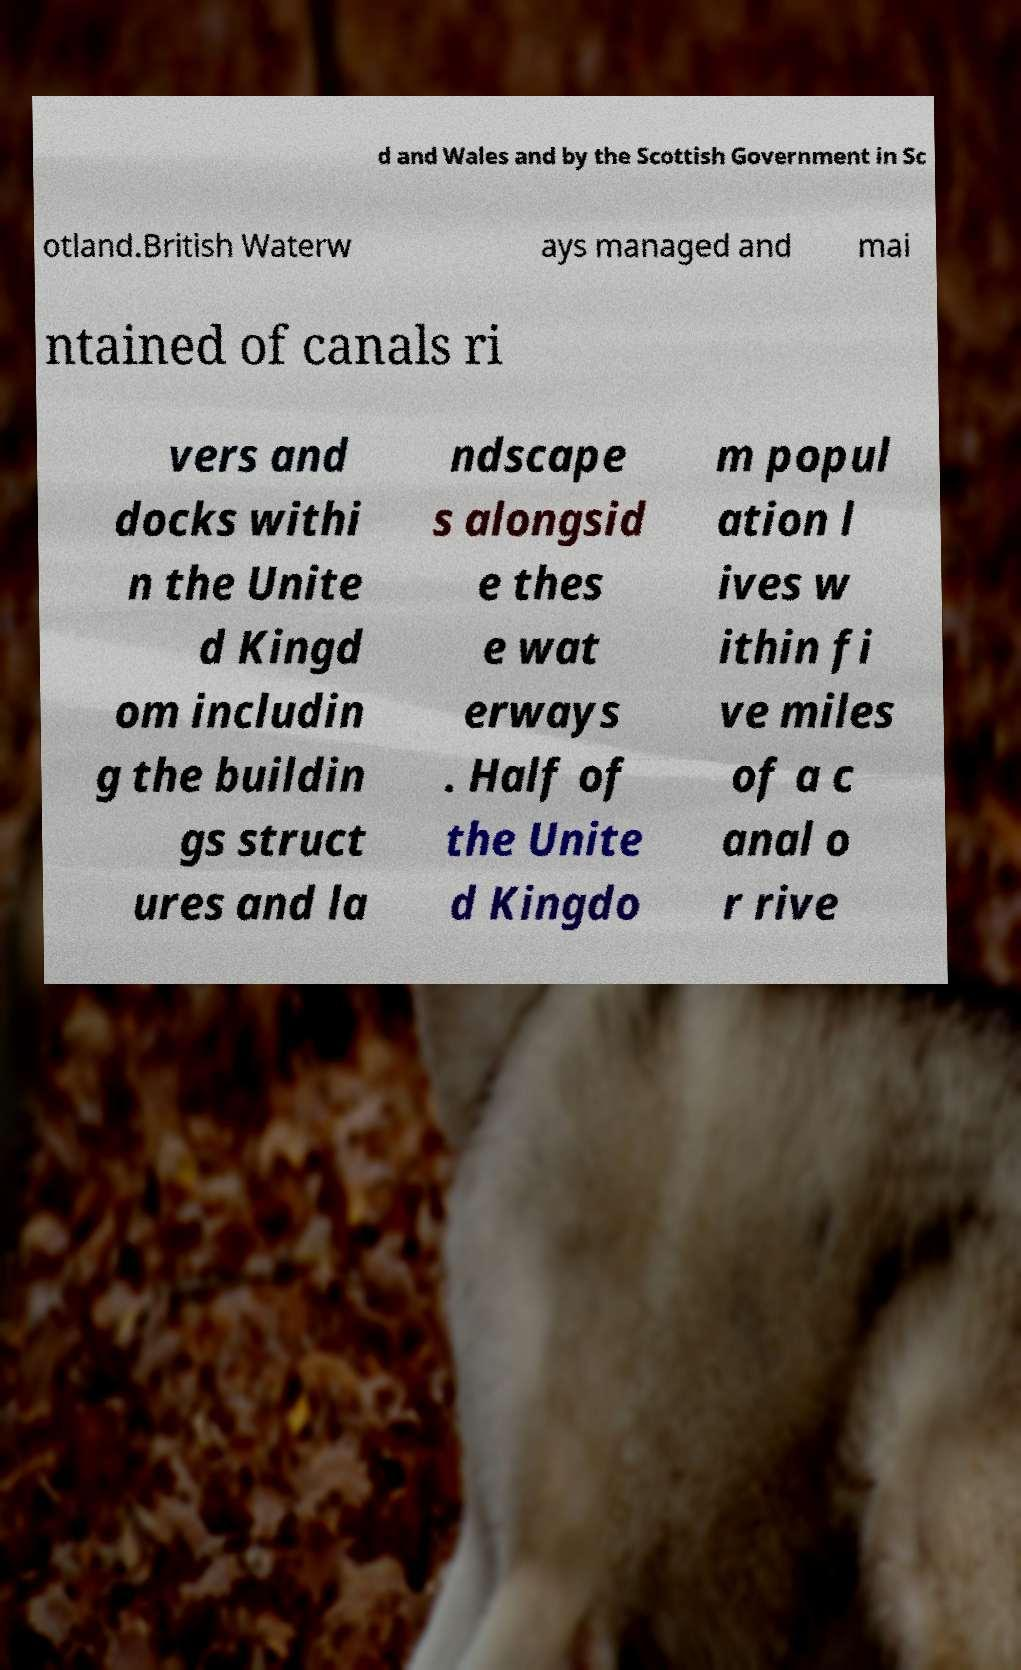Could you assist in decoding the text presented in this image and type it out clearly? d and Wales and by the Scottish Government in Sc otland.British Waterw ays managed and mai ntained of canals ri vers and docks withi n the Unite d Kingd om includin g the buildin gs struct ures and la ndscape s alongsid e thes e wat erways . Half of the Unite d Kingdo m popul ation l ives w ithin fi ve miles of a c anal o r rive 